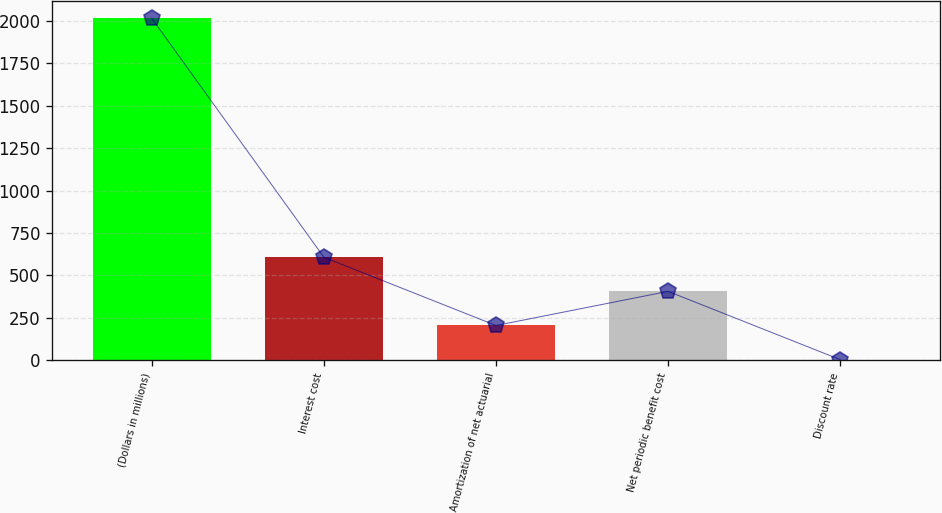<chart> <loc_0><loc_0><loc_500><loc_500><bar_chart><fcel>(Dollars in millions)<fcel>Interest cost<fcel>Amortization of net actuarial<fcel>Net periodic benefit cost<fcel>Discount rate<nl><fcel>2015<fcel>607.16<fcel>204.92<fcel>406.04<fcel>3.8<nl></chart> 